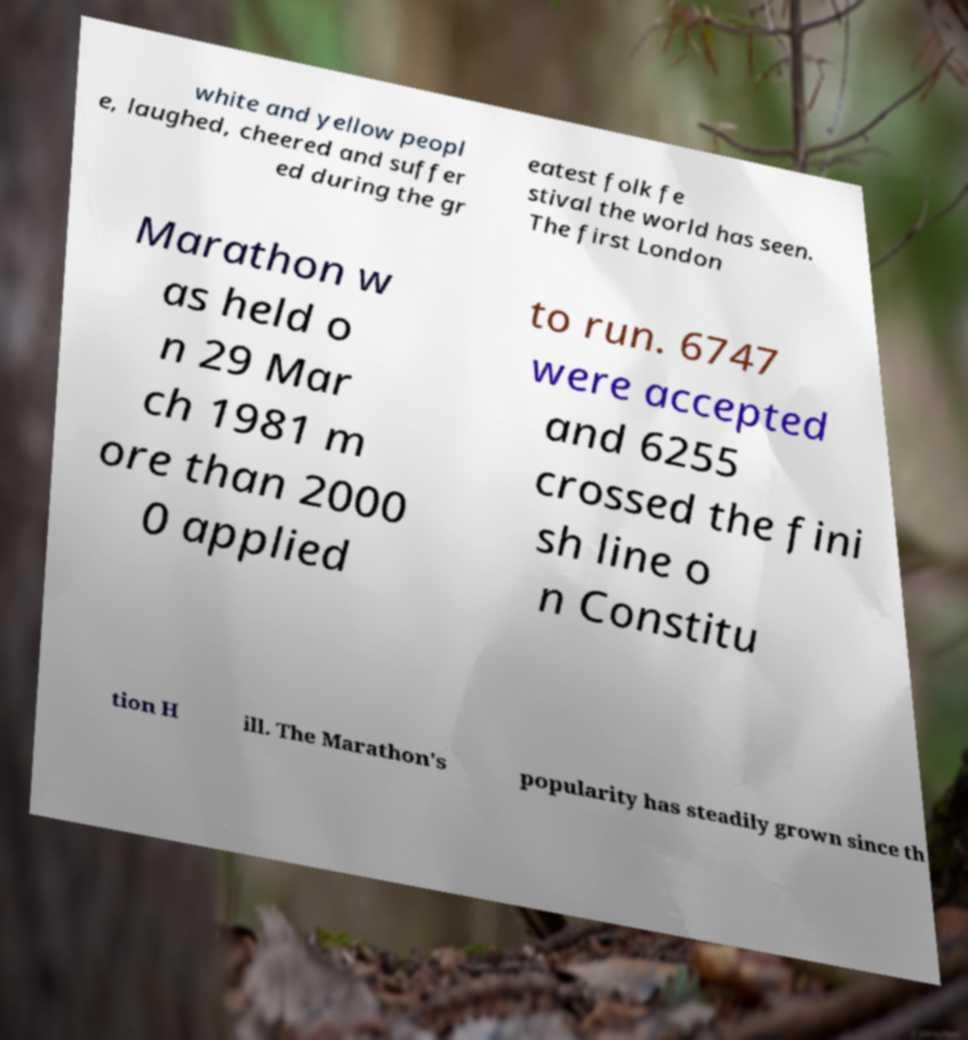Can you accurately transcribe the text from the provided image for me? white and yellow peopl e, laughed, cheered and suffer ed during the gr eatest folk fe stival the world has seen. The first London Marathon w as held o n 29 Mar ch 1981 m ore than 2000 0 applied to run. 6747 were accepted and 6255 crossed the fini sh line o n Constitu tion H ill. The Marathon's popularity has steadily grown since th 